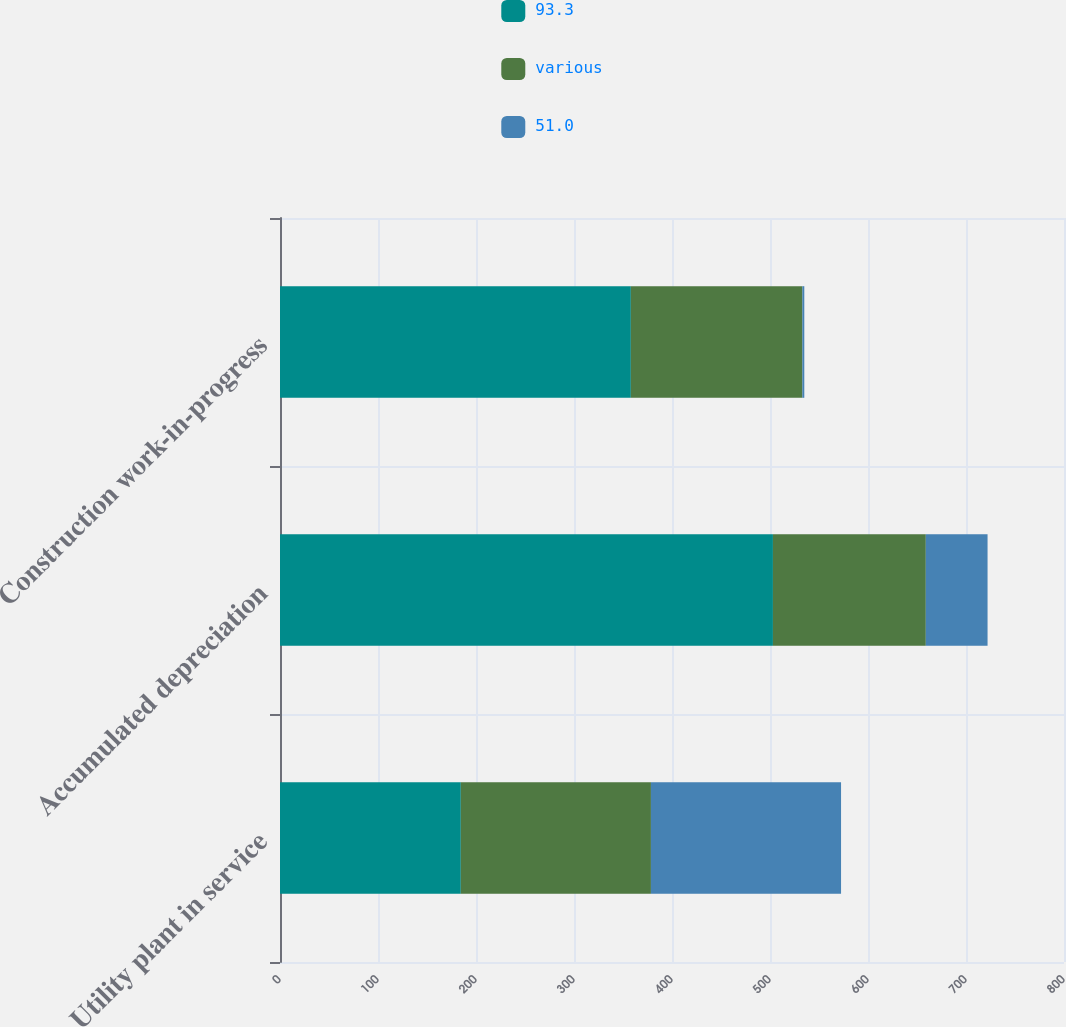Convert chart. <chart><loc_0><loc_0><loc_500><loc_500><stacked_bar_chart><ecel><fcel>Utility plant in service<fcel>Accumulated depreciation<fcel>Construction work-in-progress<nl><fcel>93.3<fcel>184.5<fcel>503<fcel>358<nl><fcel>various<fcel>194<fcel>156<fcel>175<nl><fcel>51.0<fcel>194<fcel>63<fcel>2<nl></chart> 